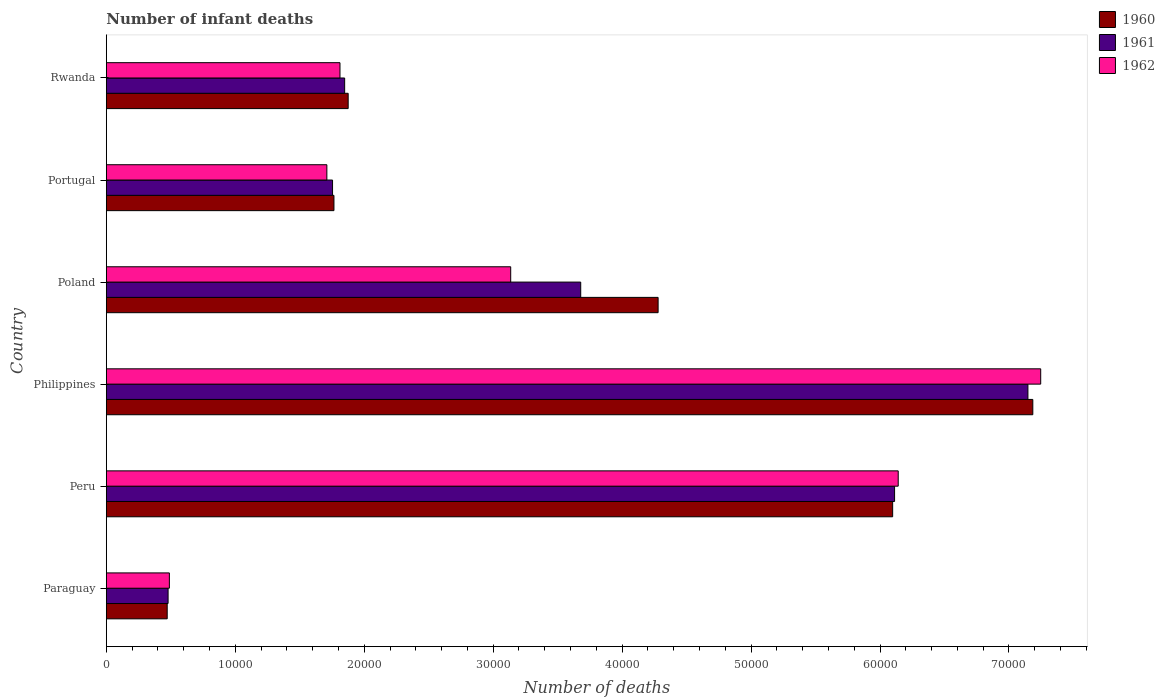How many bars are there on the 5th tick from the top?
Your answer should be compact. 3. What is the label of the 6th group of bars from the top?
Offer a terse response. Paraguay. What is the number of infant deaths in 1960 in Rwanda?
Make the answer very short. 1.88e+04. Across all countries, what is the maximum number of infant deaths in 1960?
Your answer should be very brief. 7.18e+04. Across all countries, what is the minimum number of infant deaths in 1962?
Offer a very short reply. 4889. In which country was the number of infant deaths in 1962 maximum?
Your response must be concise. Philippines. In which country was the number of infant deaths in 1962 minimum?
Provide a succinct answer. Paraguay. What is the total number of infant deaths in 1960 in the graph?
Give a very brief answer. 2.17e+05. What is the difference between the number of infant deaths in 1962 in Philippines and that in Portugal?
Give a very brief answer. 5.54e+04. What is the difference between the number of infant deaths in 1961 in Philippines and the number of infant deaths in 1960 in Portugal?
Keep it short and to the point. 5.38e+04. What is the average number of infant deaths in 1961 per country?
Make the answer very short. 3.50e+04. What is the difference between the number of infant deaths in 1961 and number of infant deaths in 1962 in Portugal?
Give a very brief answer. 441. What is the ratio of the number of infant deaths in 1961 in Paraguay to that in Poland?
Your response must be concise. 0.13. What is the difference between the highest and the second highest number of infant deaths in 1961?
Keep it short and to the point. 1.03e+04. What is the difference between the highest and the lowest number of infant deaths in 1960?
Give a very brief answer. 6.71e+04. What does the 3rd bar from the top in Portugal represents?
Your response must be concise. 1960. What does the 1st bar from the bottom in Rwanda represents?
Ensure brevity in your answer.  1960. Is it the case that in every country, the sum of the number of infant deaths in 1962 and number of infant deaths in 1960 is greater than the number of infant deaths in 1961?
Give a very brief answer. Yes. How many bars are there?
Your answer should be compact. 18. What is the difference between two consecutive major ticks on the X-axis?
Offer a terse response. 10000. Are the values on the major ticks of X-axis written in scientific E-notation?
Your response must be concise. No. Does the graph contain any zero values?
Provide a short and direct response. No. How many legend labels are there?
Your answer should be very brief. 3. How are the legend labels stacked?
Make the answer very short. Vertical. What is the title of the graph?
Make the answer very short. Number of infant deaths. Does "1969" appear as one of the legend labels in the graph?
Give a very brief answer. No. What is the label or title of the X-axis?
Your answer should be very brief. Number of deaths. What is the Number of deaths of 1960 in Paraguay?
Your response must be concise. 4720. What is the Number of deaths in 1961 in Paraguay?
Ensure brevity in your answer.  4789. What is the Number of deaths of 1962 in Paraguay?
Ensure brevity in your answer.  4889. What is the Number of deaths of 1960 in Peru?
Ensure brevity in your answer.  6.10e+04. What is the Number of deaths of 1961 in Peru?
Keep it short and to the point. 6.11e+04. What is the Number of deaths of 1962 in Peru?
Provide a short and direct response. 6.14e+04. What is the Number of deaths in 1960 in Philippines?
Give a very brief answer. 7.18e+04. What is the Number of deaths in 1961 in Philippines?
Provide a short and direct response. 7.15e+04. What is the Number of deaths in 1962 in Philippines?
Ensure brevity in your answer.  7.25e+04. What is the Number of deaths of 1960 in Poland?
Your answer should be compact. 4.28e+04. What is the Number of deaths in 1961 in Poland?
Offer a very short reply. 3.68e+04. What is the Number of deaths of 1962 in Poland?
Offer a terse response. 3.14e+04. What is the Number of deaths of 1960 in Portugal?
Provide a succinct answer. 1.77e+04. What is the Number of deaths in 1961 in Portugal?
Your response must be concise. 1.75e+04. What is the Number of deaths in 1962 in Portugal?
Provide a succinct answer. 1.71e+04. What is the Number of deaths of 1960 in Rwanda?
Give a very brief answer. 1.88e+04. What is the Number of deaths in 1961 in Rwanda?
Your answer should be compact. 1.85e+04. What is the Number of deaths in 1962 in Rwanda?
Keep it short and to the point. 1.81e+04. Across all countries, what is the maximum Number of deaths of 1960?
Your answer should be very brief. 7.18e+04. Across all countries, what is the maximum Number of deaths in 1961?
Make the answer very short. 7.15e+04. Across all countries, what is the maximum Number of deaths in 1962?
Your answer should be very brief. 7.25e+04. Across all countries, what is the minimum Number of deaths in 1960?
Your answer should be compact. 4720. Across all countries, what is the minimum Number of deaths in 1961?
Your answer should be very brief. 4789. Across all countries, what is the minimum Number of deaths in 1962?
Provide a succinct answer. 4889. What is the total Number of deaths of 1960 in the graph?
Keep it short and to the point. 2.17e+05. What is the total Number of deaths of 1961 in the graph?
Provide a short and direct response. 2.10e+05. What is the total Number of deaths of 1962 in the graph?
Keep it short and to the point. 2.05e+05. What is the difference between the Number of deaths of 1960 in Paraguay and that in Peru?
Your response must be concise. -5.63e+04. What is the difference between the Number of deaths of 1961 in Paraguay and that in Peru?
Your answer should be compact. -5.63e+04. What is the difference between the Number of deaths of 1962 in Paraguay and that in Peru?
Give a very brief answer. -5.65e+04. What is the difference between the Number of deaths in 1960 in Paraguay and that in Philippines?
Ensure brevity in your answer.  -6.71e+04. What is the difference between the Number of deaths of 1961 in Paraguay and that in Philippines?
Offer a very short reply. -6.67e+04. What is the difference between the Number of deaths in 1962 in Paraguay and that in Philippines?
Offer a very short reply. -6.76e+04. What is the difference between the Number of deaths in 1960 in Paraguay and that in Poland?
Your answer should be very brief. -3.81e+04. What is the difference between the Number of deaths of 1961 in Paraguay and that in Poland?
Give a very brief answer. -3.20e+04. What is the difference between the Number of deaths of 1962 in Paraguay and that in Poland?
Make the answer very short. -2.65e+04. What is the difference between the Number of deaths of 1960 in Paraguay and that in Portugal?
Make the answer very short. -1.29e+04. What is the difference between the Number of deaths of 1961 in Paraguay and that in Portugal?
Make the answer very short. -1.28e+04. What is the difference between the Number of deaths in 1962 in Paraguay and that in Portugal?
Offer a very short reply. -1.22e+04. What is the difference between the Number of deaths of 1960 in Paraguay and that in Rwanda?
Ensure brevity in your answer.  -1.40e+04. What is the difference between the Number of deaths of 1961 in Paraguay and that in Rwanda?
Offer a very short reply. -1.37e+04. What is the difference between the Number of deaths in 1962 in Paraguay and that in Rwanda?
Offer a terse response. -1.32e+04. What is the difference between the Number of deaths of 1960 in Peru and that in Philippines?
Give a very brief answer. -1.09e+04. What is the difference between the Number of deaths of 1961 in Peru and that in Philippines?
Make the answer very short. -1.03e+04. What is the difference between the Number of deaths of 1962 in Peru and that in Philippines?
Keep it short and to the point. -1.11e+04. What is the difference between the Number of deaths of 1960 in Peru and that in Poland?
Your response must be concise. 1.82e+04. What is the difference between the Number of deaths in 1961 in Peru and that in Poland?
Keep it short and to the point. 2.43e+04. What is the difference between the Number of deaths in 1962 in Peru and that in Poland?
Ensure brevity in your answer.  3.01e+04. What is the difference between the Number of deaths in 1960 in Peru and that in Portugal?
Offer a terse response. 4.33e+04. What is the difference between the Number of deaths of 1961 in Peru and that in Portugal?
Give a very brief answer. 4.36e+04. What is the difference between the Number of deaths of 1962 in Peru and that in Portugal?
Ensure brevity in your answer.  4.43e+04. What is the difference between the Number of deaths in 1960 in Peru and that in Rwanda?
Offer a terse response. 4.22e+04. What is the difference between the Number of deaths in 1961 in Peru and that in Rwanda?
Make the answer very short. 4.26e+04. What is the difference between the Number of deaths of 1962 in Peru and that in Rwanda?
Your answer should be compact. 4.33e+04. What is the difference between the Number of deaths of 1960 in Philippines and that in Poland?
Your answer should be compact. 2.91e+04. What is the difference between the Number of deaths of 1961 in Philippines and that in Poland?
Offer a terse response. 3.47e+04. What is the difference between the Number of deaths of 1962 in Philippines and that in Poland?
Your response must be concise. 4.11e+04. What is the difference between the Number of deaths in 1960 in Philippines and that in Portugal?
Offer a terse response. 5.42e+04. What is the difference between the Number of deaths in 1961 in Philippines and that in Portugal?
Make the answer very short. 5.39e+04. What is the difference between the Number of deaths in 1962 in Philippines and that in Portugal?
Offer a very short reply. 5.54e+04. What is the difference between the Number of deaths in 1960 in Philippines and that in Rwanda?
Offer a very short reply. 5.31e+04. What is the difference between the Number of deaths in 1961 in Philippines and that in Rwanda?
Provide a succinct answer. 5.30e+04. What is the difference between the Number of deaths in 1962 in Philippines and that in Rwanda?
Offer a terse response. 5.43e+04. What is the difference between the Number of deaths of 1960 in Poland and that in Portugal?
Provide a short and direct response. 2.51e+04. What is the difference between the Number of deaths in 1961 in Poland and that in Portugal?
Make the answer very short. 1.92e+04. What is the difference between the Number of deaths in 1962 in Poland and that in Portugal?
Keep it short and to the point. 1.43e+04. What is the difference between the Number of deaths in 1960 in Poland and that in Rwanda?
Make the answer very short. 2.40e+04. What is the difference between the Number of deaths of 1961 in Poland and that in Rwanda?
Offer a very short reply. 1.83e+04. What is the difference between the Number of deaths of 1962 in Poland and that in Rwanda?
Ensure brevity in your answer.  1.32e+04. What is the difference between the Number of deaths in 1960 in Portugal and that in Rwanda?
Your response must be concise. -1103. What is the difference between the Number of deaths in 1961 in Portugal and that in Rwanda?
Your answer should be compact. -939. What is the difference between the Number of deaths of 1962 in Portugal and that in Rwanda?
Provide a succinct answer. -1018. What is the difference between the Number of deaths in 1960 in Paraguay and the Number of deaths in 1961 in Peru?
Your response must be concise. -5.64e+04. What is the difference between the Number of deaths of 1960 in Paraguay and the Number of deaths of 1962 in Peru?
Offer a terse response. -5.67e+04. What is the difference between the Number of deaths of 1961 in Paraguay and the Number of deaths of 1962 in Peru?
Your answer should be very brief. -5.66e+04. What is the difference between the Number of deaths of 1960 in Paraguay and the Number of deaths of 1961 in Philippines?
Ensure brevity in your answer.  -6.68e+04. What is the difference between the Number of deaths of 1960 in Paraguay and the Number of deaths of 1962 in Philippines?
Give a very brief answer. -6.77e+04. What is the difference between the Number of deaths in 1961 in Paraguay and the Number of deaths in 1962 in Philippines?
Give a very brief answer. -6.77e+04. What is the difference between the Number of deaths of 1960 in Paraguay and the Number of deaths of 1961 in Poland?
Make the answer very short. -3.21e+04. What is the difference between the Number of deaths in 1960 in Paraguay and the Number of deaths in 1962 in Poland?
Provide a succinct answer. -2.66e+04. What is the difference between the Number of deaths of 1961 in Paraguay and the Number of deaths of 1962 in Poland?
Ensure brevity in your answer.  -2.66e+04. What is the difference between the Number of deaths of 1960 in Paraguay and the Number of deaths of 1961 in Portugal?
Give a very brief answer. -1.28e+04. What is the difference between the Number of deaths of 1960 in Paraguay and the Number of deaths of 1962 in Portugal?
Make the answer very short. -1.24e+04. What is the difference between the Number of deaths in 1961 in Paraguay and the Number of deaths in 1962 in Portugal?
Your answer should be compact. -1.23e+04. What is the difference between the Number of deaths of 1960 in Paraguay and the Number of deaths of 1961 in Rwanda?
Give a very brief answer. -1.38e+04. What is the difference between the Number of deaths of 1960 in Paraguay and the Number of deaths of 1962 in Rwanda?
Your answer should be compact. -1.34e+04. What is the difference between the Number of deaths of 1961 in Paraguay and the Number of deaths of 1962 in Rwanda?
Your answer should be very brief. -1.33e+04. What is the difference between the Number of deaths of 1960 in Peru and the Number of deaths of 1961 in Philippines?
Offer a terse response. -1.05e+04. What is the difference between the Number of deaths in 1960 in Peru and the Number of deaths in 1962 in Philippines?
Give a very brief answer. -1.15e+04. What is the difference between the Number of deaths of 1961 in Peru and the Number of deaths of 1962 in Philippines?
Keep it short and to the point. -1.13e+04. What is the difference between the Number of deaths in 1960 in Peru and the Number of deaths in 1961 in Poland?
Provide a short and direct response. 2.42e+04. What is the difference between the Number of deaths in 1960 in Peru and the Number of deaths in 1962 in Poland?
Provide a short and direct response. 2.96e+04. What is the difference between the Number of deaths in 1961 in Peru and the Number of deaths in 1962 in Poland?
Keep it short and to the point. 2.98e+04. What is the difference between the Number of deaths of 1960 in Peru and the Number of deaths of 1961 in Portugal?
Keep it short and to the point. 4.34e+04. What is the difference between the Number of deaths in 1960 in Peru and the Number of deaths in 1962 in Portugal?
Provide a short and direct response. 4.39e+04. What is the difference between the Number of deaths in 1961 in Peru and the Number of deaths in 1962 in Portugal?
Your answer should be compact. 4.40e+04. What is the difference between the Number of deaths of 1960 in Peru and the Number of deaths of 1961 in Rwanda?
Ensure brevity in your answer.  4.25e+04. What is the difference between the Number of deaths in 1960 in Peru and the Number of deaths in 1962 in Rwanda?
Give a very brief answer. 4.29e+04. What is the difference between the Number of deaths of 1961 in Peru and the Number of deaths of 1962 in Rwanda?
Your response must be concise. 4.30e+04. What is the difference between the Number of deaths in 1960 in Philippines and the Number of deaths in 1961 in Poland?
Your answer should be very brief. 3.51e+04. What is the difference between the Number of deaths of 1960 in Philippines and the Number of deaths of 1962 in Poland?
Give a very brief answer. 4.05e+04. What is the difference between the Number of deaths of 1961 in Philippines and the Number of deaths of 1962 in Poland?
Provide a short and direct response. 4.01e+04. What is the difference between the Number of deaths in 1960 in Philippines and the Number of deaths in 1961 in Portugal?
Provide a short and direct response. 5.43e+04. What is the difference between the Number of deaths in 1960 in Philippines and the Number of deaths in 1962 in Portugal?
Keep it short and to the point. 5.47e+04. What is the difference between the Number of deaths of 1961 in Philippines and the Number of deaths of 1962 in Portugal?
Make the answer very short. 5.44e+04. What is the difference between the Number of deaths in 1960 in Philippines and the Number of deaths in 1961 in Rwanda?
Your response must be concise. 5.34e+04. What is the difference between the Number of deaths of 1960 in Philippines and the Number of deaths of 1962 in Rwanda?
Provide a short and direct response. 5.37e+04. What is the difference between the Number of deaths of 1961 in Philippines and the Number of deaths of 1962 in Rwanda?
Keep it short and to the point. 5.34e+04. What is the difference between the Number of deaths in 1960 in Poland and the Number of deaths in 1961 in Portugal?
Ensure brevity in your answer.  2.52e+04. What is the difference between the Number of deaths in 1960 in Poland and the Number of deaths in 1962 in Portugal?
Ensure brevity in your answer.  2.57e+04. What is the difference between the Number of deaths in 1961 in Poland and the Number of deaths in 1962 in Portugal?
Your answer should be compact. 1.97e+04. What is the difference between the Number of deaths in 1960 in Poland and the Number of deaths in 1961 in Rwanda?
Make the answer very short. 2.43e+04. What is the difference between the Number of deaths of 1960 in Poland and the Number of deaths of 1962 in Rwanda?
Make the answer very short. 2.47e+04. What is the difference between the Number of deaths in 1961 in Poland and the Number of deaths in 1962 in Rwanda?
Offer a very short reply. 1.87e+04. What is the difference between the Number of deaths in 1960 in Portugal and the Number of deaths in 1961 in Rwanda?
Make the answer very short. -830. What is the difference between the Number of deaths in 1960 in Portugal and the Number of deaths in 1962 in Rwanda?
Offer a terse response. -468. What is the difference between the Number of deaths in 1961 in Portugal and the Number of deaths in 1962 in Rwanda?
Your answer should be very brief. -577. What is the average Number of deaths of 1960 per country?
Ensure brevity in your answer.  3.61e+04. What is the average Number of deaths in 1961 per country?
Provide a short and direct response. 3.50e+04. What is the average Number of deaths of 1962 per country?
Keep it short and to the point. 3.42e+04. What is the difference between the Number of deaths in 1960 and Number of deaths in 1961 in Paraguay?
Keep it short and to the point. -69. What is the difference between the Number of deaths of 1960 and Number of deaths of 1962 in Paraguay?
Your answer should be very brief. -169. What is the difference between the Number of deaths in 1961 and Number of deaths in 1962 in Paraguay?
Provide a short and direct response. -100. What is the difference between the Number of deaths in 1960 and Number of deaths in 1961 in Peru?
Give a very brief answer. -149. What is the difference between the Number of deaths in 1960 and Number of deaths in 1962 in Peru?
Give a very brief answer. -431. What is the difference between the Number of deaths of 1961 and Number of deaths of 1962 in Peru?
Provide a short and direct response. -282. What is the difference between the Number of deaths of 1960 and Number of deaths of 1961 in Philippines?
Keep it short and to the point. 380. What is the difference between the Number of deaths in 1960 and Number of deaths in 1962 in Philippines?
Give a very brief answer. -612. What is the difference between the Number of deaths in 1961 and Number of deaths in 1962 in Philippines?
Your answer should be very brief. -992. What is the difference between the Number of deaths of 1960 and Number of deaths of 1961 in Poland?
Your answer should be compact. 6002. What is the difference between the Number of deaths of 1960 and Number of deaths of 1962 in Poland?
Give a very brief answer. 1.14e+04. What is the difference between the Number of deaths in 1961 and Number of deaths in 1962 in Poland?
Provide a short and direct response. 5430. What is the difference between the Number of deaths in 1960 and Number of deaths in 1961 in Portugal?
Your answer should be compact. 109. What is the difference between the Number of deaths of 1960 and Number of deaths of 1962 in Portugal?
Offer a terse response. 550. What is the difference between the Number of deaths in 1961 and Number of deaths in 1962 in Portugal?
Make the answer very short. 441. What is the difference between the Number of deaths in 1960 and Number of deaths in 1961 in Rwanda?
Ensure brevity in your answer.  273. What is the difference between the Number of deaths in 1960 and Number of deaths in 1962 in Rwanda?
Offer a very short reply. 635. What is the difference between the Number of deaths of 1961 and Number of deaths of 1962 in Rwanda?
Your response must be concise. 362. What is the ratio of the Number of deaths in 1960 in Paraguay to that in Peru?
Make the answer very short. 0.08. What is the ratio of the Number of deaths in 1961 in Paraguay to that in Peru?
Ensure brevity in your answer.  0.08. What is the ratio of the Number of deaths of 1962 in Paraguay to that in Peru?
Offer a terse response. 0.08. What is the ratio of the Number of deaths of 1960 in Paraguay to that in Philippines?
Offer a terse response. 0.07. What is the ratio of the Number of deaths of 1961 in Paraguay to that in Philippines?
Give a very brief answer. 0.07. What is the ratio of the Number of deaths of 1962 in Paraguay to that in Philippines?
Offer a terse response. 0.07. What is the ratio of the Number of deaths in 1960 in Paraguay to that in Poland?
Offer a very short reply. 0.11. What is the ratio of the Number of deaths in 1961 in Paraguay to that in Poland?
Provide a short and direct response. 0.13. What is the ratio of the Number of deaths in 1962 in Paraguay to that in Poland?
Your answer should be very brief. 0.16. What is the ratio of the Number of deaths of 1960 in Paraguay to that in Portugal?
Offer a terse response. 0.27. What is the ratio of the Number of deaths in 1961 in Paraguay to that in Portugal?
Make the answer very short. 0.27. What is the ratio of the Number of deaths in 1962 in Paraguay to that in Portugal?
Your response must be concise. 0.29. What is the ratio of the Number of deaths of 1960 in Paraguay to that in Rwanda?
Give a very brief answer. 0.25. What is the ratio of the Number of deaths in 1961 in Paraguay to that in Rwanda?
Provide a succinct answer. 0.26. What is the ratio of the Number of deaths of 1962 in Paraguay to that in Rwanda?
Keep it short and to the point. 0.27. What is the ratio of the Number of deaths of 1960 in Peru to that in Philippines?
Provide a short and direct response. 0.85. What is the ratio of the Number of deaths in 1961 in Peru to that in Philippines?
Your answer should be very brief. 0.86. What is the ratio of the Number of deaths in 1962 in Peru to that in Philippines?
Offer a terse response. 0.85. What is the ratio of the Number of deaths of 1960 in Peru to that in Poland?
Make the answer very short. 1.43. What is the ratio of the Number of deaths of 1961 in Peru to that in Poland?
Provide a succinct answer. 1.66. What is the ratio of the Number of deaths of 1962 in Peru to that in Poland?
Make the answer very short. 1.96. What is the ratio of the Number of deaths in 1960 in Peru to that in Portugal?
Give a very brief answer. 3.45. What is the ratio of the Number of deaths in 1961 in Peru to that in Portugal?
Keep it short and to the point. 3.48. What is the ratio of the Number of deaths of 1962 in Peru to that in Portugal?
Your answer should be compact. 3.59. What is the ratio of the Number of deaths of 1960 in Peru to that in Rwanda?
Provide a short and direct response. 3.25. What is the ratio of the Number of deaths in 1961 in Peru to that in Rwanda?
Give a very brief answer. 3.31. What is the ratio of the Number of deaths of 1962 in Peru to that in Rwanda?
Your answer should be very brief. 3.39. What is the ratio of the Number of deaths in 1960 in Philippines to that in Poland?
Your answer should be very brief. 1.68. What is the ratio of the Number of deaths of 1961 in Philippines to that in Poland?
Your response must be concise. 1.94. What is the ratio of the Number of deaths in 1962 in Philippines to that in Poland?
Keep it short and to the point. 2.31. What is the ratio of the Number of deaths in 1960 in Philippines to that in Portugal?
Offer a very short reply. 4.07. What is the ratio of the Number of deaths in 1961 in Philippines to that in Portugal?
Your answer should be very brief. 4.07. What is the ratio of the Number of deaths in 1962 in Philippines to that in Portugal?
Offer a very short reply. 4.24. What is the ratio of the Number of deaths of 1960 in Philippines to that in Rwanda?
Offer a very short reply. 3.83. What is the ratio of the Number of deaths of 1961 in Philippines to that in Rwanda?
Offer a very short reply. 3.87. What is the ratio of the Number of deaths in 1962 in Philippines to that in Rwanda?
Ensure brevity in your answer.  4. What is the ratio of the Number of deaths in 1960 in Poland to that in Portugal?
Your answer should be very brief. 2.42. What is the ratio of the Number of deaths in 1961 in Poland to that in Portugal?
Provide a short and direct response. 2.1. What is the ratio of the Number of deaths of 1962 in Poland to that in Portugal?
Offer a terse response. 1.83. What is the ratio of the Number of deaths of 1960 in Poland to that in Rwanda?
Ensure brevity in your answer.  2.28. What is the ratio of the Number of deaths of 1961 in Poland to that in Rwanda?
Your response must be concise. 1.99. What is the ratio of the Number of deaths in 1962 in Poland to that in Rwanda?
Ensure brevity in your answer.  1.73. What is the ratio of the Number of deaths in 1961 in Portugal to that in Rwanda?
Provide a short and direct response. 0.95. What is the ratio of the Number of deaths in 1962 in Portugal to that in Rwanda?
Offer a terse response. 0.94. What is the difference between the highest and the second highest Number of deaths in 1960?
Your answer should be compact. 1.09e+04. What is the difference between the highest and the second highest Number of deaths in 1961?
Give a very brief answer. 1.03e+04. What is the difference between the highest and the second highest Number of deaths of 1962?
Offer a very short reply. 1.11e+04. What is the difference between the highest and the lowest Number of deaths in 1960?
Ensure brevity in your answer.  6.71e+04. What is the difference between the highest and the lowest Number of deaths of 1961?
Your answer should be very brief. 6.67e+04. What is the difference between the highest and the lowest Number of deaths of 1962?
Offer a very short reply. 6.76e+04. 